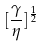Convert formula to latex. <formula><loc_0><loc_0><loc_500><loc_500>[ \frac { \gamma } { \eta } ] ^ { \frac { 1 } { 2 } }</formula> 